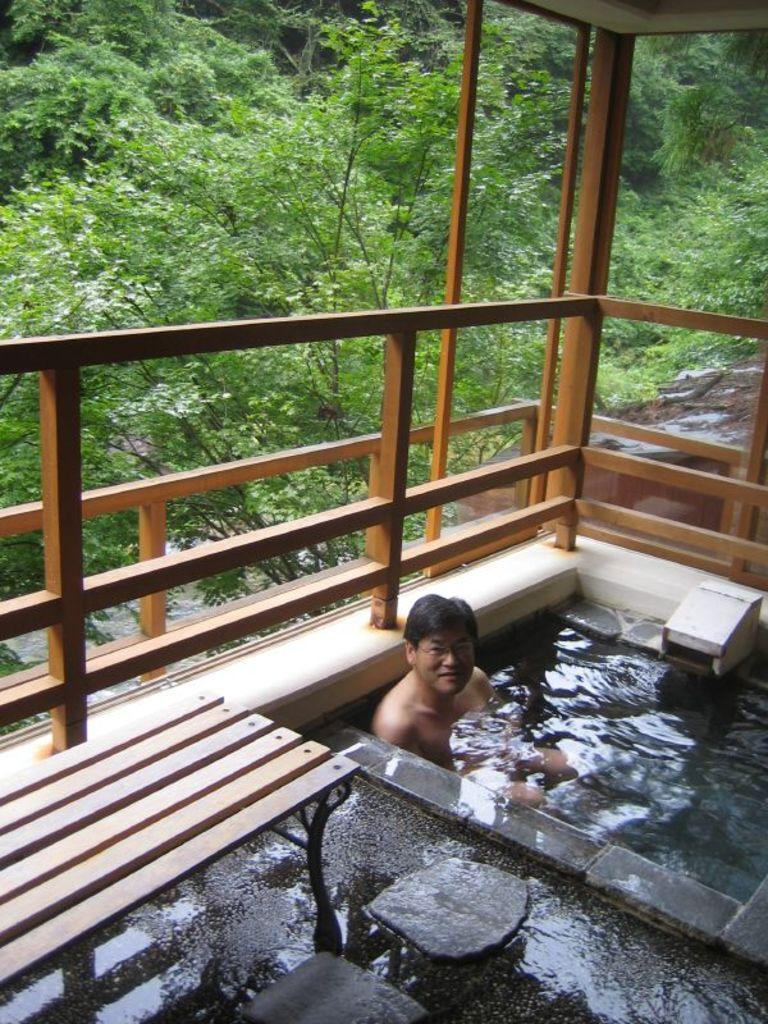What is the main object in the image? There is a bath tub in the image. What is inside the bath tub? The bath tub contains water. What additional feature is present near the bath tub? There is a bench beside the bath tub. What can be seen in the distance in the image? There are trees visible in the background of the image. What type of protest is taking place in the image? There is no protest present in the image; it features a bath tub with water and a bench. What color is the lipstick on the person in the image? There is no person or lipstick present in the image. 